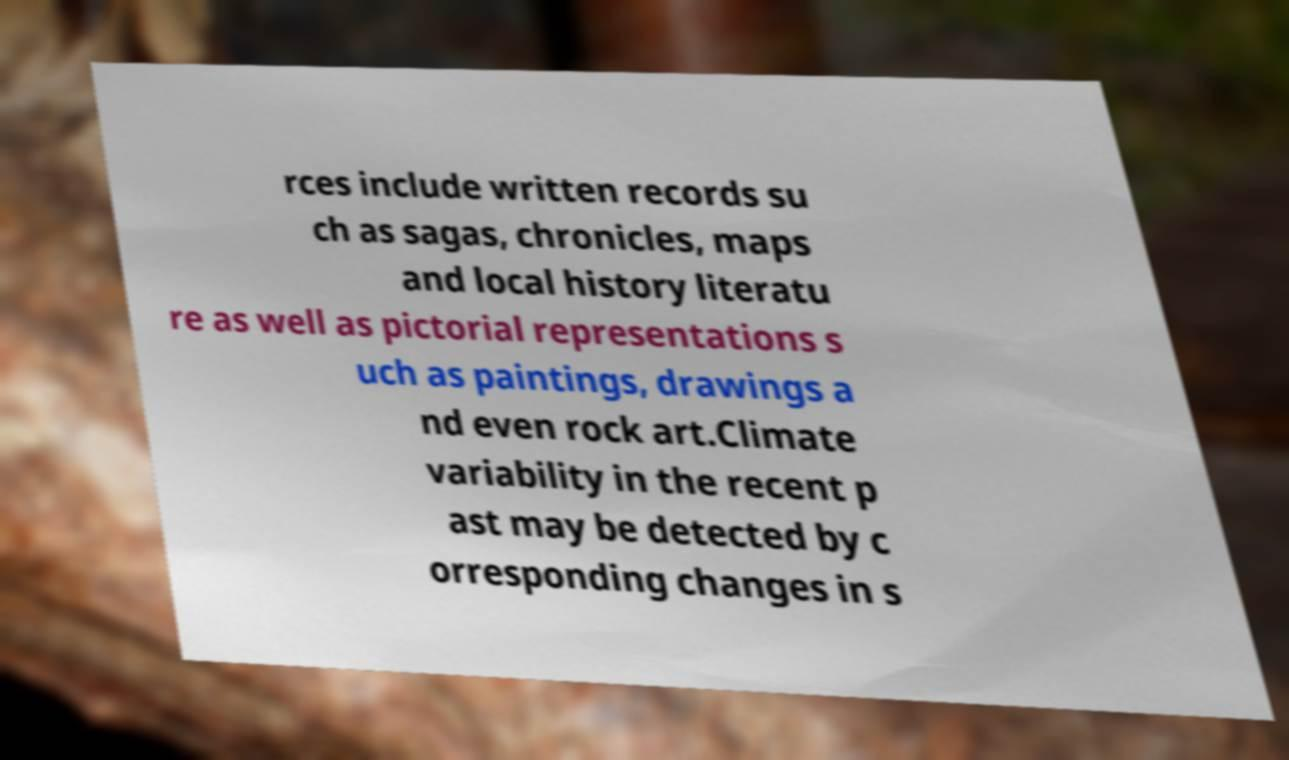There's text embedded in this image that I need extracted. Can you transcribe it verbatim? rces include written records su ch as sagas, chronicles, maps and local history literatu re as well as pictorial representations s uch as paintings, drawings a nd even rock art.Climate variability in the recent p ast may be detected by c orresponding changes in s 